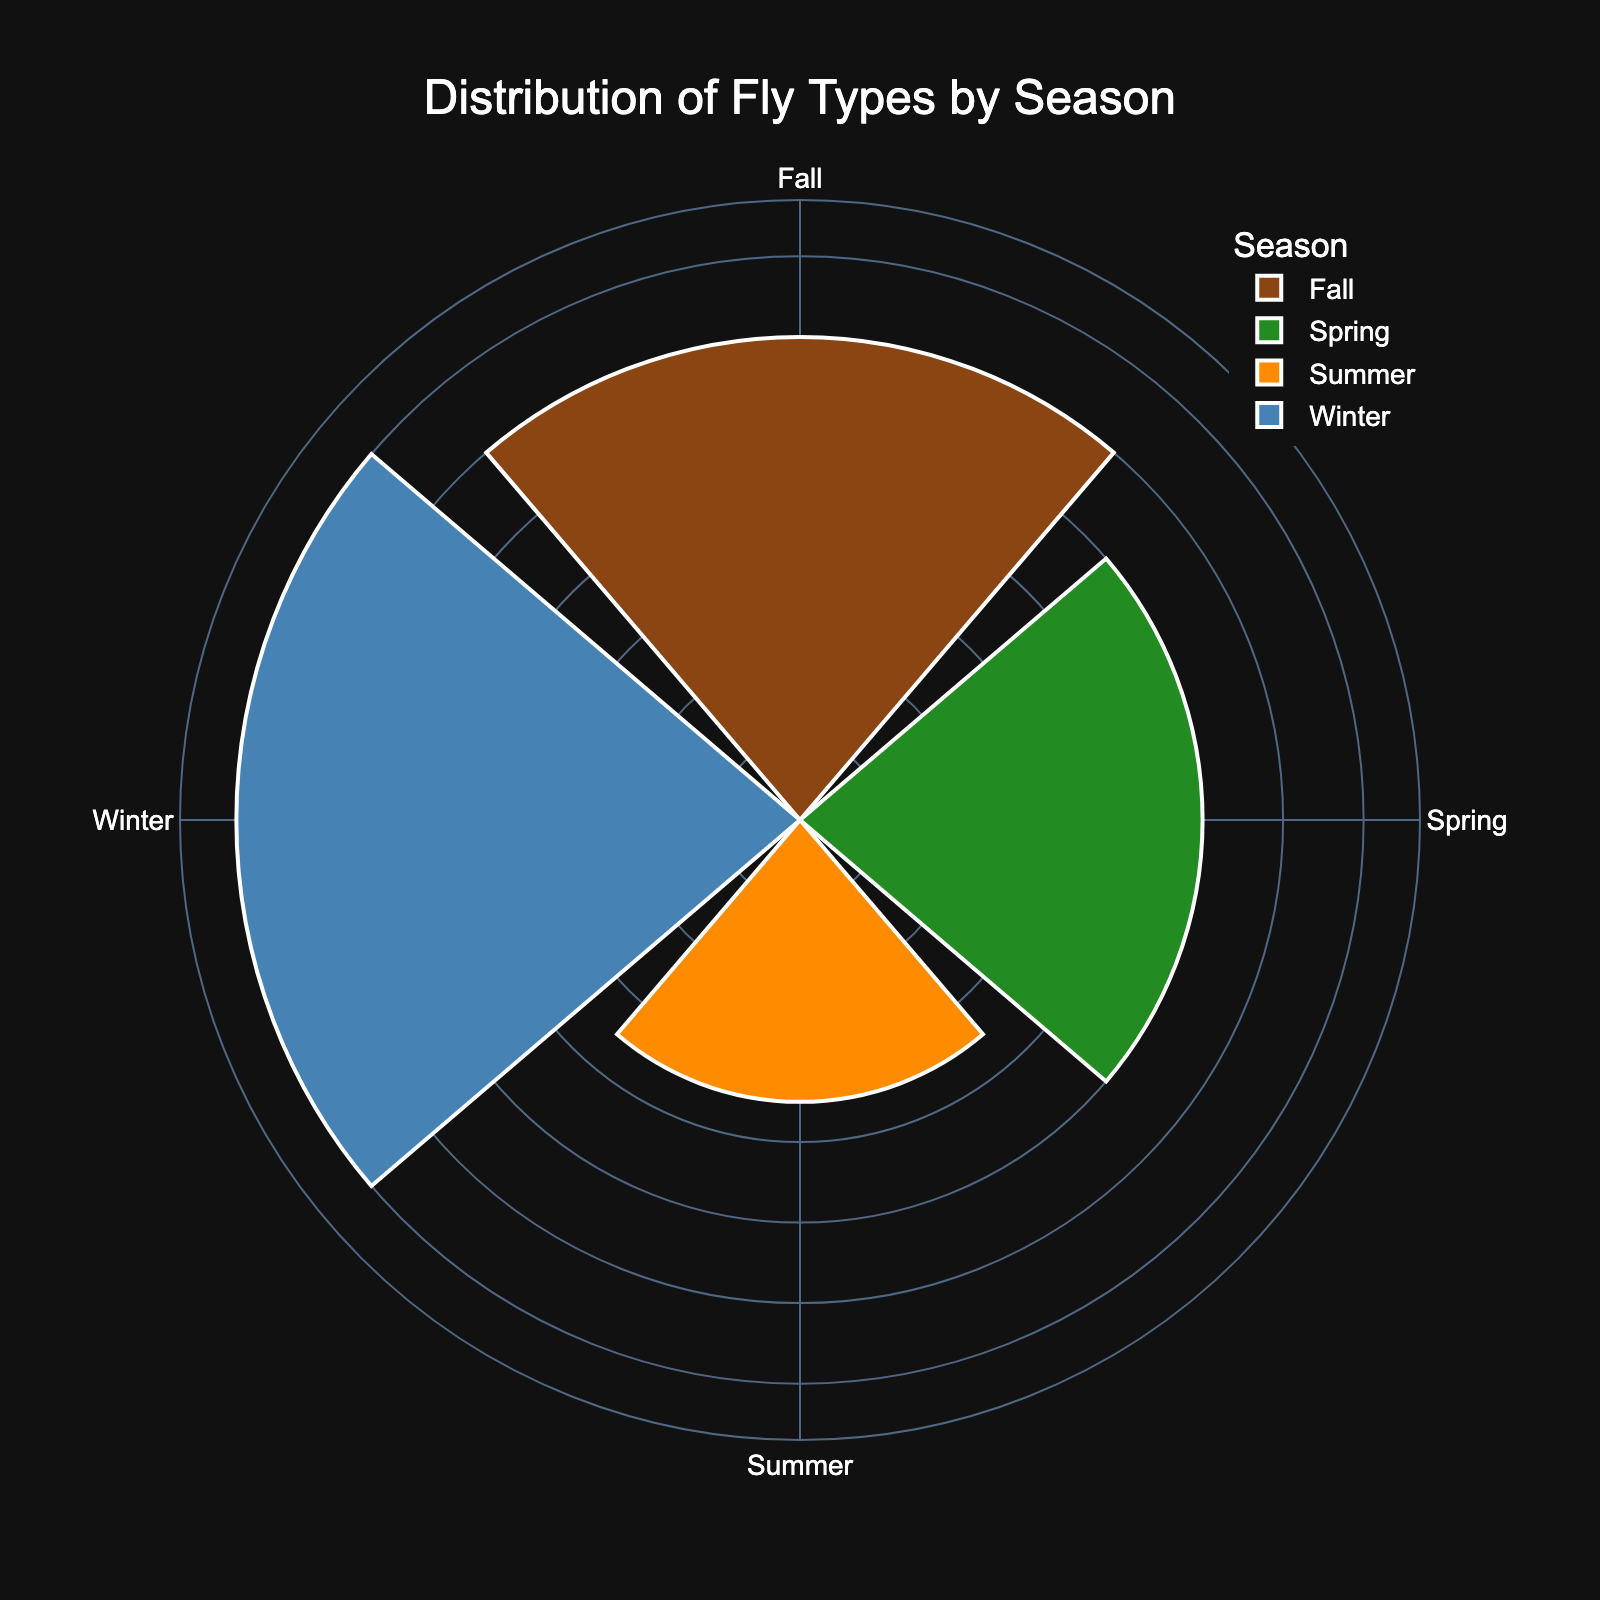What is the total count of fly types in Spring? Looking at the rose chart, add the individual counts for Caddis (35), Mayfly (45), and Stonefly (20) in Spring. The total is 35 + 45 + 20 = 100
Answer: 100 Which season has the highest sum of fly counts? From the rose chart, compare the total counts for each season: Spring (100), Summer (70), Fall (120), and Winter (140). The highest is Winter with 140
Answer: Winter What is the color associated with Fall in the chart? Observing the rose chart, the color for Fall corresponds to the third segment in the angular axis which is colored in orange
Answer: Orange How does the count of flies in Winter compare to Spring? The winter segment has a total count of 140 and the Spring segment has 100. Comparing the two, Winter has more flies than Spring
Answer: Winter What is the difference in fly counts between Fall and Summer? From the chart, total counts are Fall (120) and Summer (70). The difference is calculated by 120 - 70 = 50
Answer: 50 What percentage of the total fly count does Summer represent? Sum the counts of all seasons: Spring (100) + Summer (70) + Fall (120) + Winter (140) = 430. The percentage for Summer is (70/430) * 100 ≈ 16.28%
Answer: 16.28% Which season has the lowest count of fly types? From the rose chart, the total counts are Spring (100), Summer (70), Fall (120), and Winter (140). The lowest count is in Summer with 70
Answer: Summer 